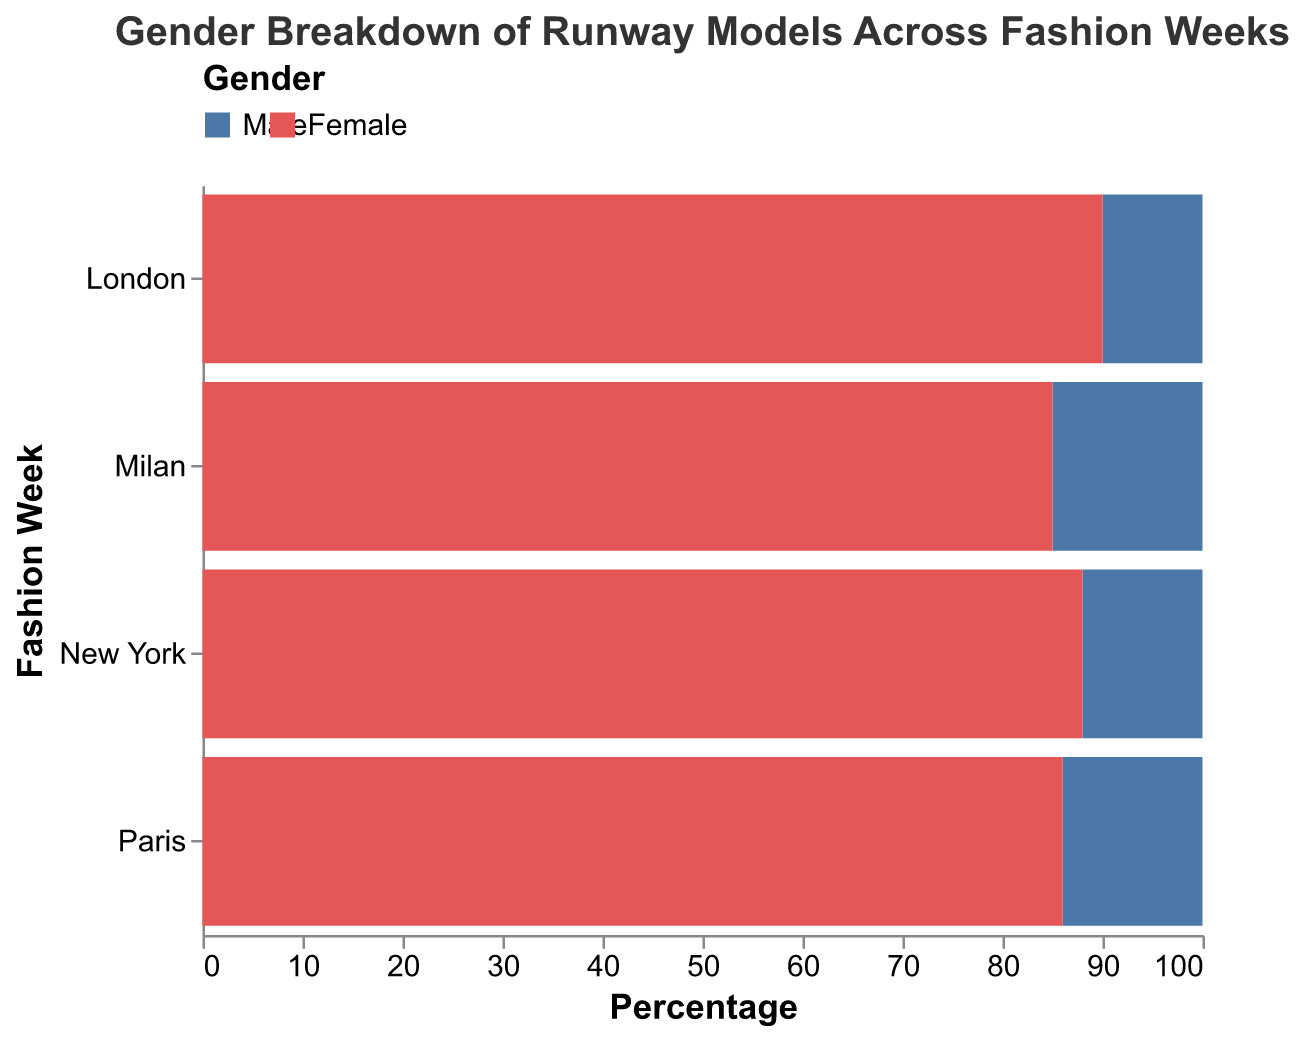What is the overall title of the figure? The title of the figure is displayed at the top.
Answer: Gender Breakdown of Runway Models Across Fashion Weeks Which gender has a higher representation across all cities? By observing the figure, all positive bars (Female) are longer than the negative bars (Male), indicating higher representation.
Answer: Female Which city has the highest percentage of male models? The longest negative bar represents the highest percentage of male models. Milan has the longest negative bar.
Answer: Milan What is the percentage difference of female models between New York and Paris? Female: New York (88) and Paris (86). Calculate the difference (88 - 86).
Answer: 2 In which city is the representation of female models compared to male models the highest? Observe the length difference between positive (Female) and negative (Male) bars for each city.
Answer: London Across all cities, which has the lowest representation of male models? The shortest negative bar represents the lowest percentage of male models. London has the shortest negative bar.
Answer: London Summarize the total percentage of female models across all cities. Add the female percentages for New York (88), London (90), Milan (85), and Paris (86). (88 + 90 + 85 + 86) = 349
Answer: 349 Compare the representation of male models in New York and Paris. Which one has a higher percentage and by how much? Male: New York (-12) and Paris (-14). Higher for New York by (-12 - -14) = 2%
Answer: New York by 2 What is the average percentage of female models across the four cities? Sum the female percentages and divide by 4. (88 + 90 + 85 + 86) / 4 = 87.25
Answer: 87.25 Which city shows the greatest gender disparity in model representation? The city with the largest difference in bar lengths between positive (Female) and negative (Male) values shows the greatest disparity.
Answer: London 